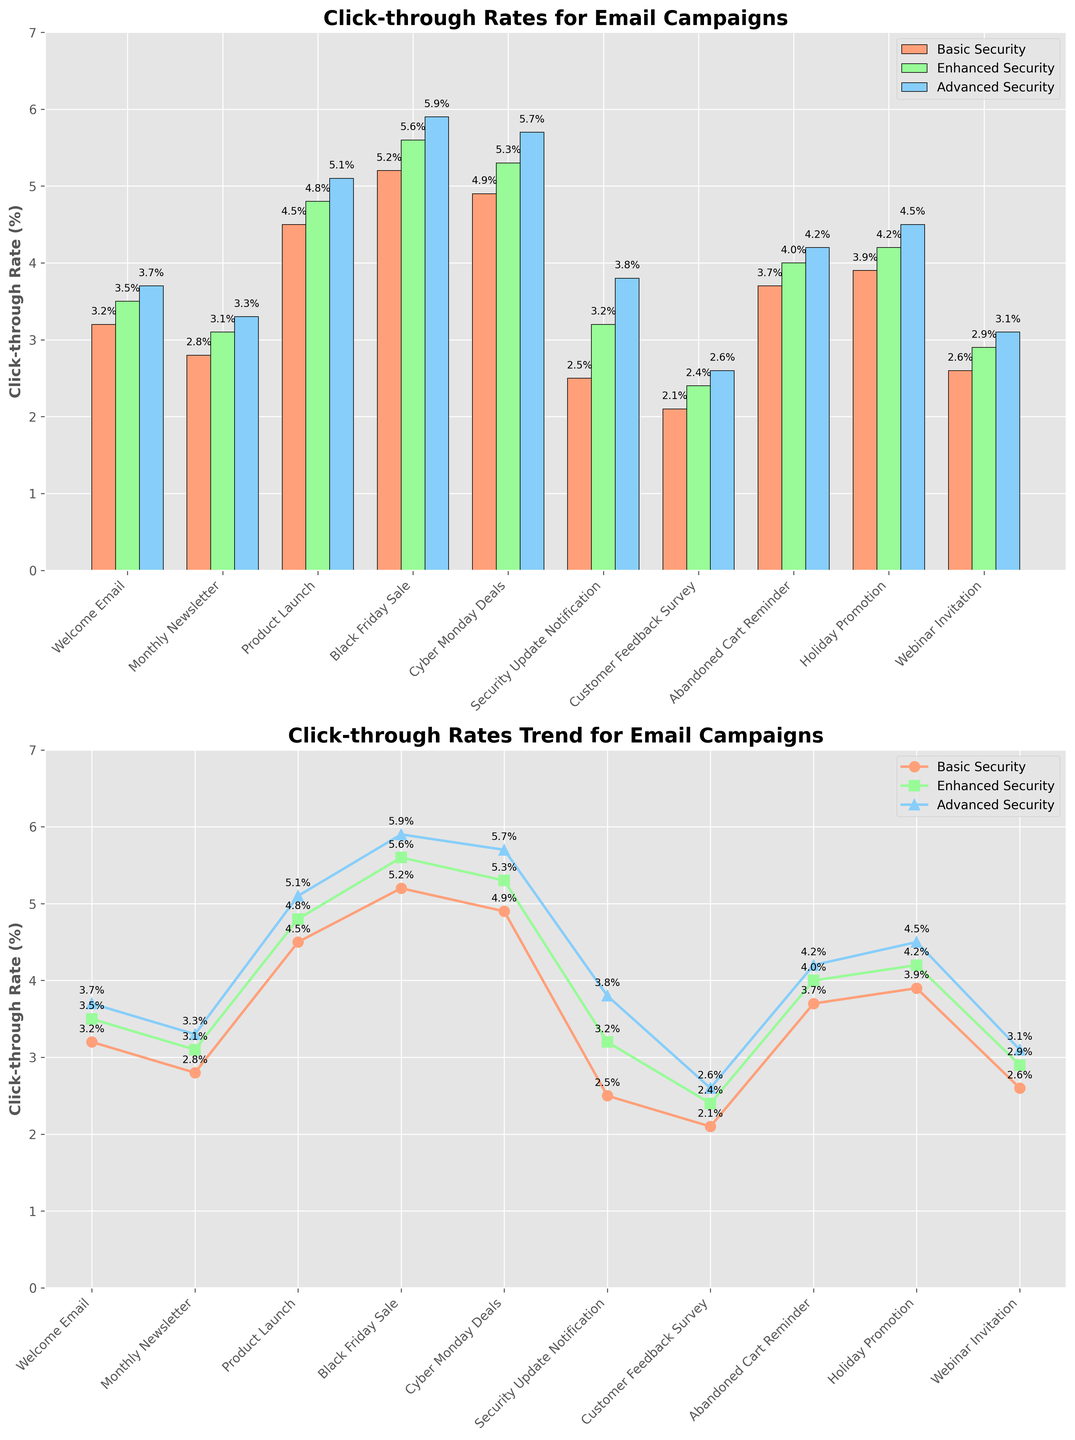What is the title of the first subplot? The title of the first subplot is usually positioned at the top of the plot. In this figure, the title for the bar plot would be read directly from the top of that plot.
Answer: Click-through Rates for Email Campaigns What is the click-through rate for the Welcome Email campaign with Enhanced Security features? To find the click-through rate for the Welcome Email campaign with Enhanced Security features, locate the Welcome Email on the x-axis and the corresponding green bar in the bar plot, which represents Enhanced Security. The label inside the green bar indicates the click-through rate.
Answer: 3.5% Which campaign has the highest click-through rate under Advanced Security? Scan the Advanced Security (blue bars in the bar plot) values across campaigns. Identify the highest value. In the bar plot, 'Black Friday Sale' and its y-value of 5.9% is the highest click-through rate. Confirm this from the step-by-step visual inspection of the blue bars.
Answer: Black Friday Sale How much does the click-through rate increase from Basic to Advanced Security for the Cyber Monday Deals campaign? Find the click-through rates for Basic and Advanced Security for the Cyber Monday Deals campaign. Basic Security is 4.9%, and Advanced Security is 5.7%. Subtract the Basic Security rate from the Advanced Security rate (5.7% - 4.9%).
Answer: 0.8% What is the average click-through rate for the Holiday Promotion campaign across all security levels? For the Holiday Promotion campaign, add the click-through rates for Basic, Enhanced, and Advanced Security (3.9% + 4.2% + 4.5%) and divide by 3 to find the average.
Answer: 4.2% Between Monthly Newsletter and Customer Feedback Survey campaigns, which one shows a greater improvement in click-through rate from Basic to Enhanced Security? Calculate the improvement by subtracting the Basic Security rate from the Enhanced Security rate for each campaign. Monthly Newsletter: 3.1% - 2.8% = 0.3%, and Customer Feedback Survey: 2.4% - 2.1% = 0.3%. Both campaigns show the same improvement of 0.3%.
Answer: Both show equal improvement In the line plot, which security level demonstrates the most consistent improvement across all campaigns? Compare the trend lines for each security level. Consistent improvement can be judged by a smooth upward trend in the line plot. The Advanced Security line (blue) consistently improves across all campaigns in the line plot.
Answer: Advanced Security Is there any campaign where the Basic and Enhanced Security click-through rates are the same? Look at the bars for each campaign in the bar plot. There is no campaign where the Basic and Enhanced Security (orange and green bars) have the same click-through rate; all show differences.
Answer: No What is the overall trend observed in click-through rates when comparing Basic to Advanced Security? Observe the differences in click-through rates between Basic and Advanced Security across all campaigns. In general, there is a clear upward trend in click-through rates from Basic to Advanced Security features, indicating an overall increase.
Answer: Upward trend 